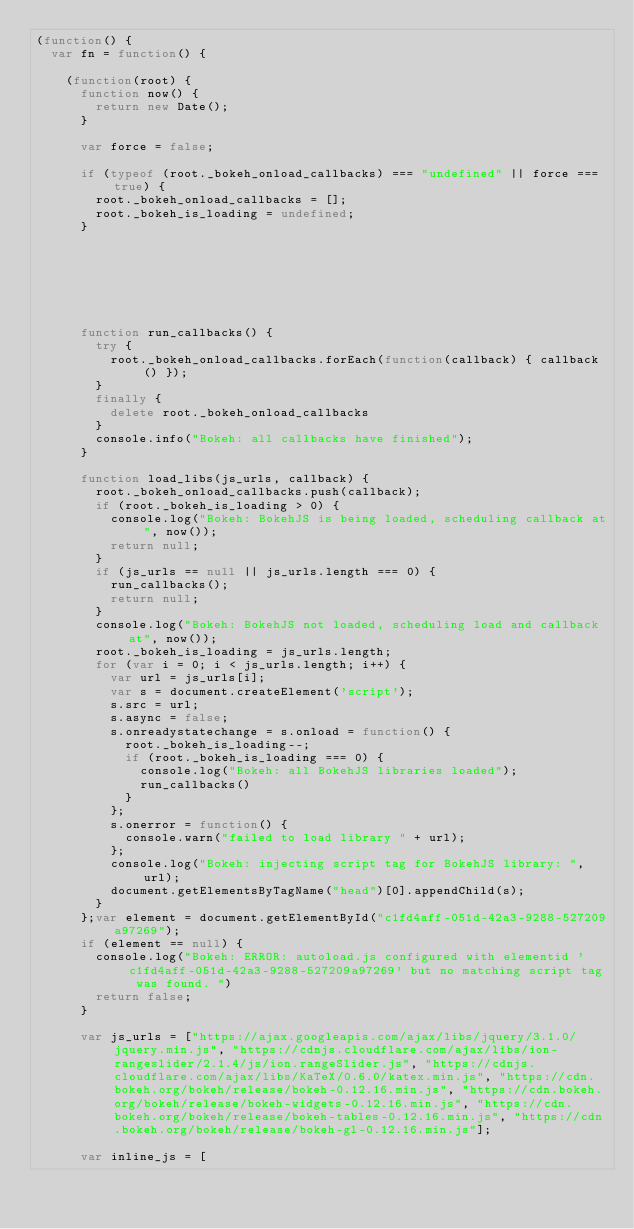Convert code to text. <code><loc_0><loc_0><loc_500><loc_500><_JavaScript_>(function() {
  var fn = function() {
    
    (function(root) {
      function now() {
        return new Date();
      }
    
      var force = false;
    
      if (typeof (root._bokeh_onload_callbacks) === "undefined" || force === true) {
        root._bokeh_onload_callbacks = [];
        root._bokeh_is_loading = undefined;
      }
    
      
      
    
      
      
    
      function run_callbacks() {
        try {
          root._bokeh_onload_callbacks.forEach(function(callback) { callback() });
        }
        finally {
          delete root._bokeh_onload_callbacks
        }
        console.info("Bokeh: all callbacks have finished");
      }
    
      function load_libs(js_urls, callback) {
        root._bokeh_onload_callbacks.push(callback);
        if (root._bokeh_is_loading > 0) {
          console.log("Bokeh: BokehJS is being loaded, scheduling callback at", now());
          return null;
        }
        if (js_urls == null || js_urls.length === 0) {
          run_callbacks();
          return null;
        }
        console.log("Bokeh: BokehJS not loaded, scheduling load and callback at", now());
        root._bokeh_is_loading = js_urls.length;
        for (var i = 0; i < js_urls.length; i++) {
          var url = js_urls[i];
          var s = document.createElement('script');
          s.src = url;
          s.async = false;
          s.onreadystatechange = s.onload = function() {
            root._bokeh_is_loading--;
            if (root._bokeh_is_loading === 0) {
              console.log("Bokeh: all BokehJS libraries loaded");
              run_callbacks()
            }
          };
          s.onerror = function() {
            console.warn("failed to load library " + url);
          };
          console.log("Bokeh: injecting script tag for BokehJS library: ", url);
          document.getElementsByTagName("head")[0].appendChild(s);
        }
      };var element = document.getElementById("c1fd4aff-051d-42a3-9288-527209a97269");
      if (element == null) {
        console.log("Bokeh: ERROR: autoload.js configured with elementid 'c1fd4aff-051d-42a3-9288-527209a97269' but no matching script tag was found. ")
        return false;
      }
    
      var js_urls = ["https://ajax.googleapis.com/ajax/libs/jquery/3.1.0/jquery.min.js", "https://cdnjs.cloudflare.com/ajax/libs/ion-rangeslider/2.1.4/js/ion.rangeSlider.js", "https://cdnjs.cloudflare.com/ajax/libs/KaTeX/0.6.0/katex.min.js", "https://cdn.bokeh.org/bokeh/release/bokeh-0.12.16.min.js", "https://cdn.bokeh.org/bokeh/release/bokeh-widgets-0.12.16.min.js", "https://cdn.bokeh.org/bokeh/release/bokeh-tables-0.12.16.min.js", "https://cdn.bokeh.org/bokeh/release/bokeh-gl-0.12.16.min.js"];
    
      var inline_js = [</code> 